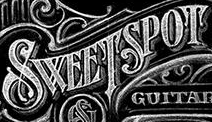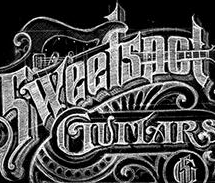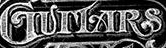Transcribe the words shown in these images in order, separated by a semicolon. SWEETSPOT; Sweetspot; GUITARS 